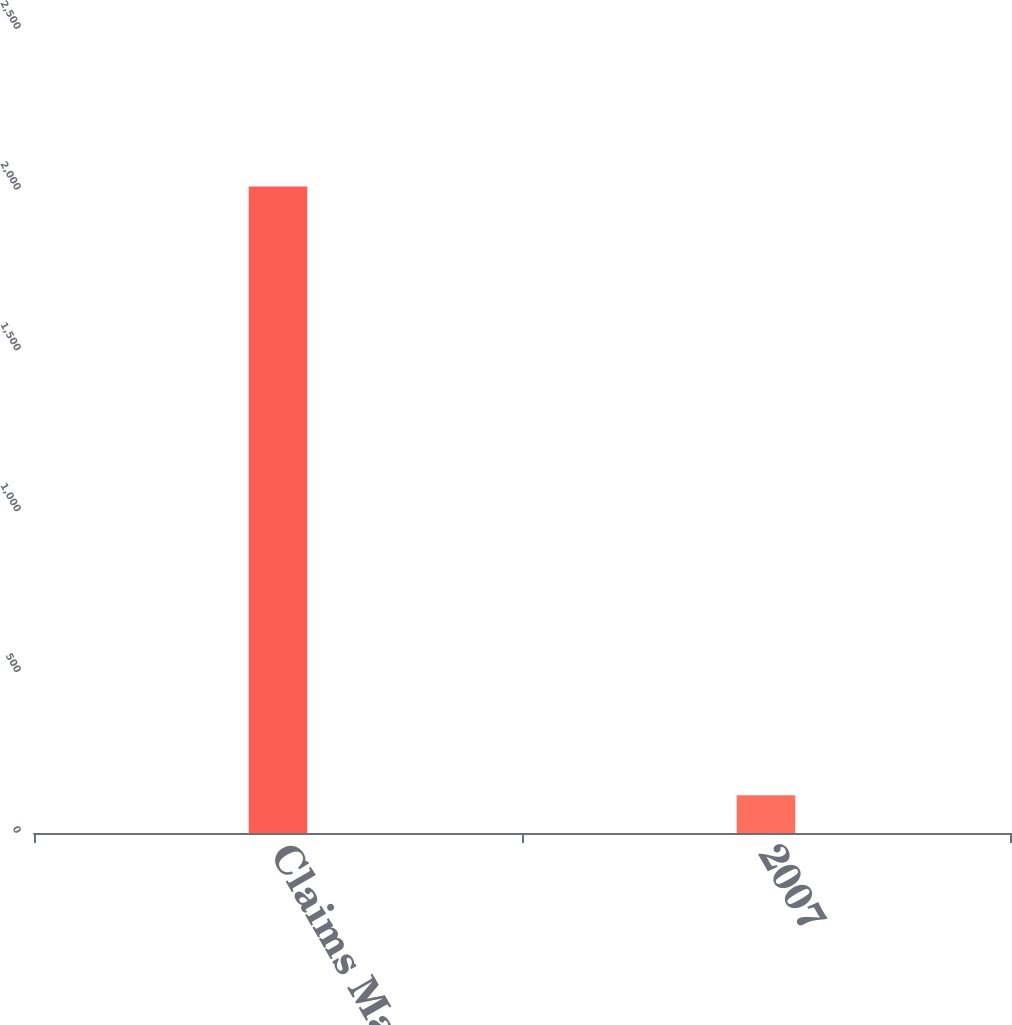Convert chart to OTSL. <chart><loc_0><loc_0><loc_500><loc_500><bar_chart><fcel>Claims Made Year<fcel>2007<nl><fcel>2010<fcel>117<nl></chart> 